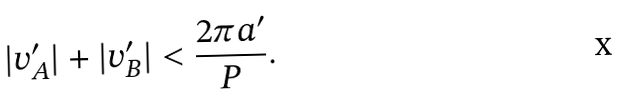<formula> <loc_0><loc_0><loc_500><loc_500>| v _ { A } ^ { \prime } | + | v _ { B } ^ { \prime } | < \frac { 2 \pi a ^ { \prime } } { P } .</formula> 